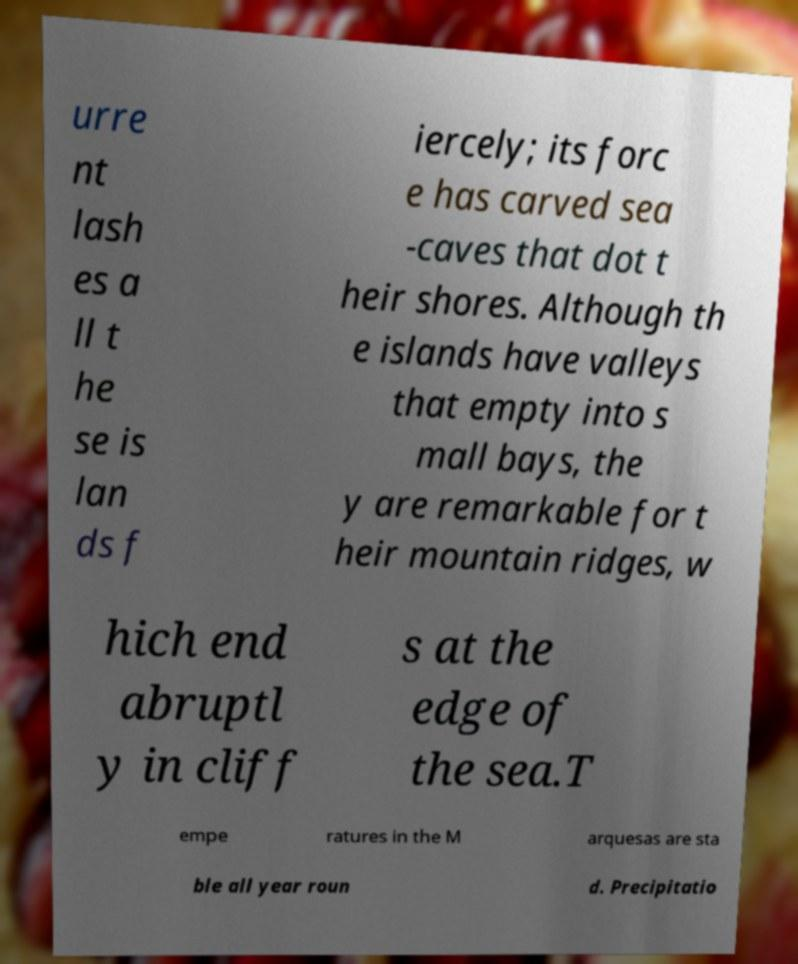What messages or text are displayed in this image? I need them in a readable, typed format. urre nt lash es a ll t he se is lan ds f iercely; its forc e has carved sea -caves that dot t heir shores. Although th e islands have valleys that empty into s mall bays, the y are remarkable for t heir mountain ridges, w hich end abruptl y in cliff s at the edge of the sea.T empe ratures in the M arquesas are sta ble all year roun d. Precipitatio 